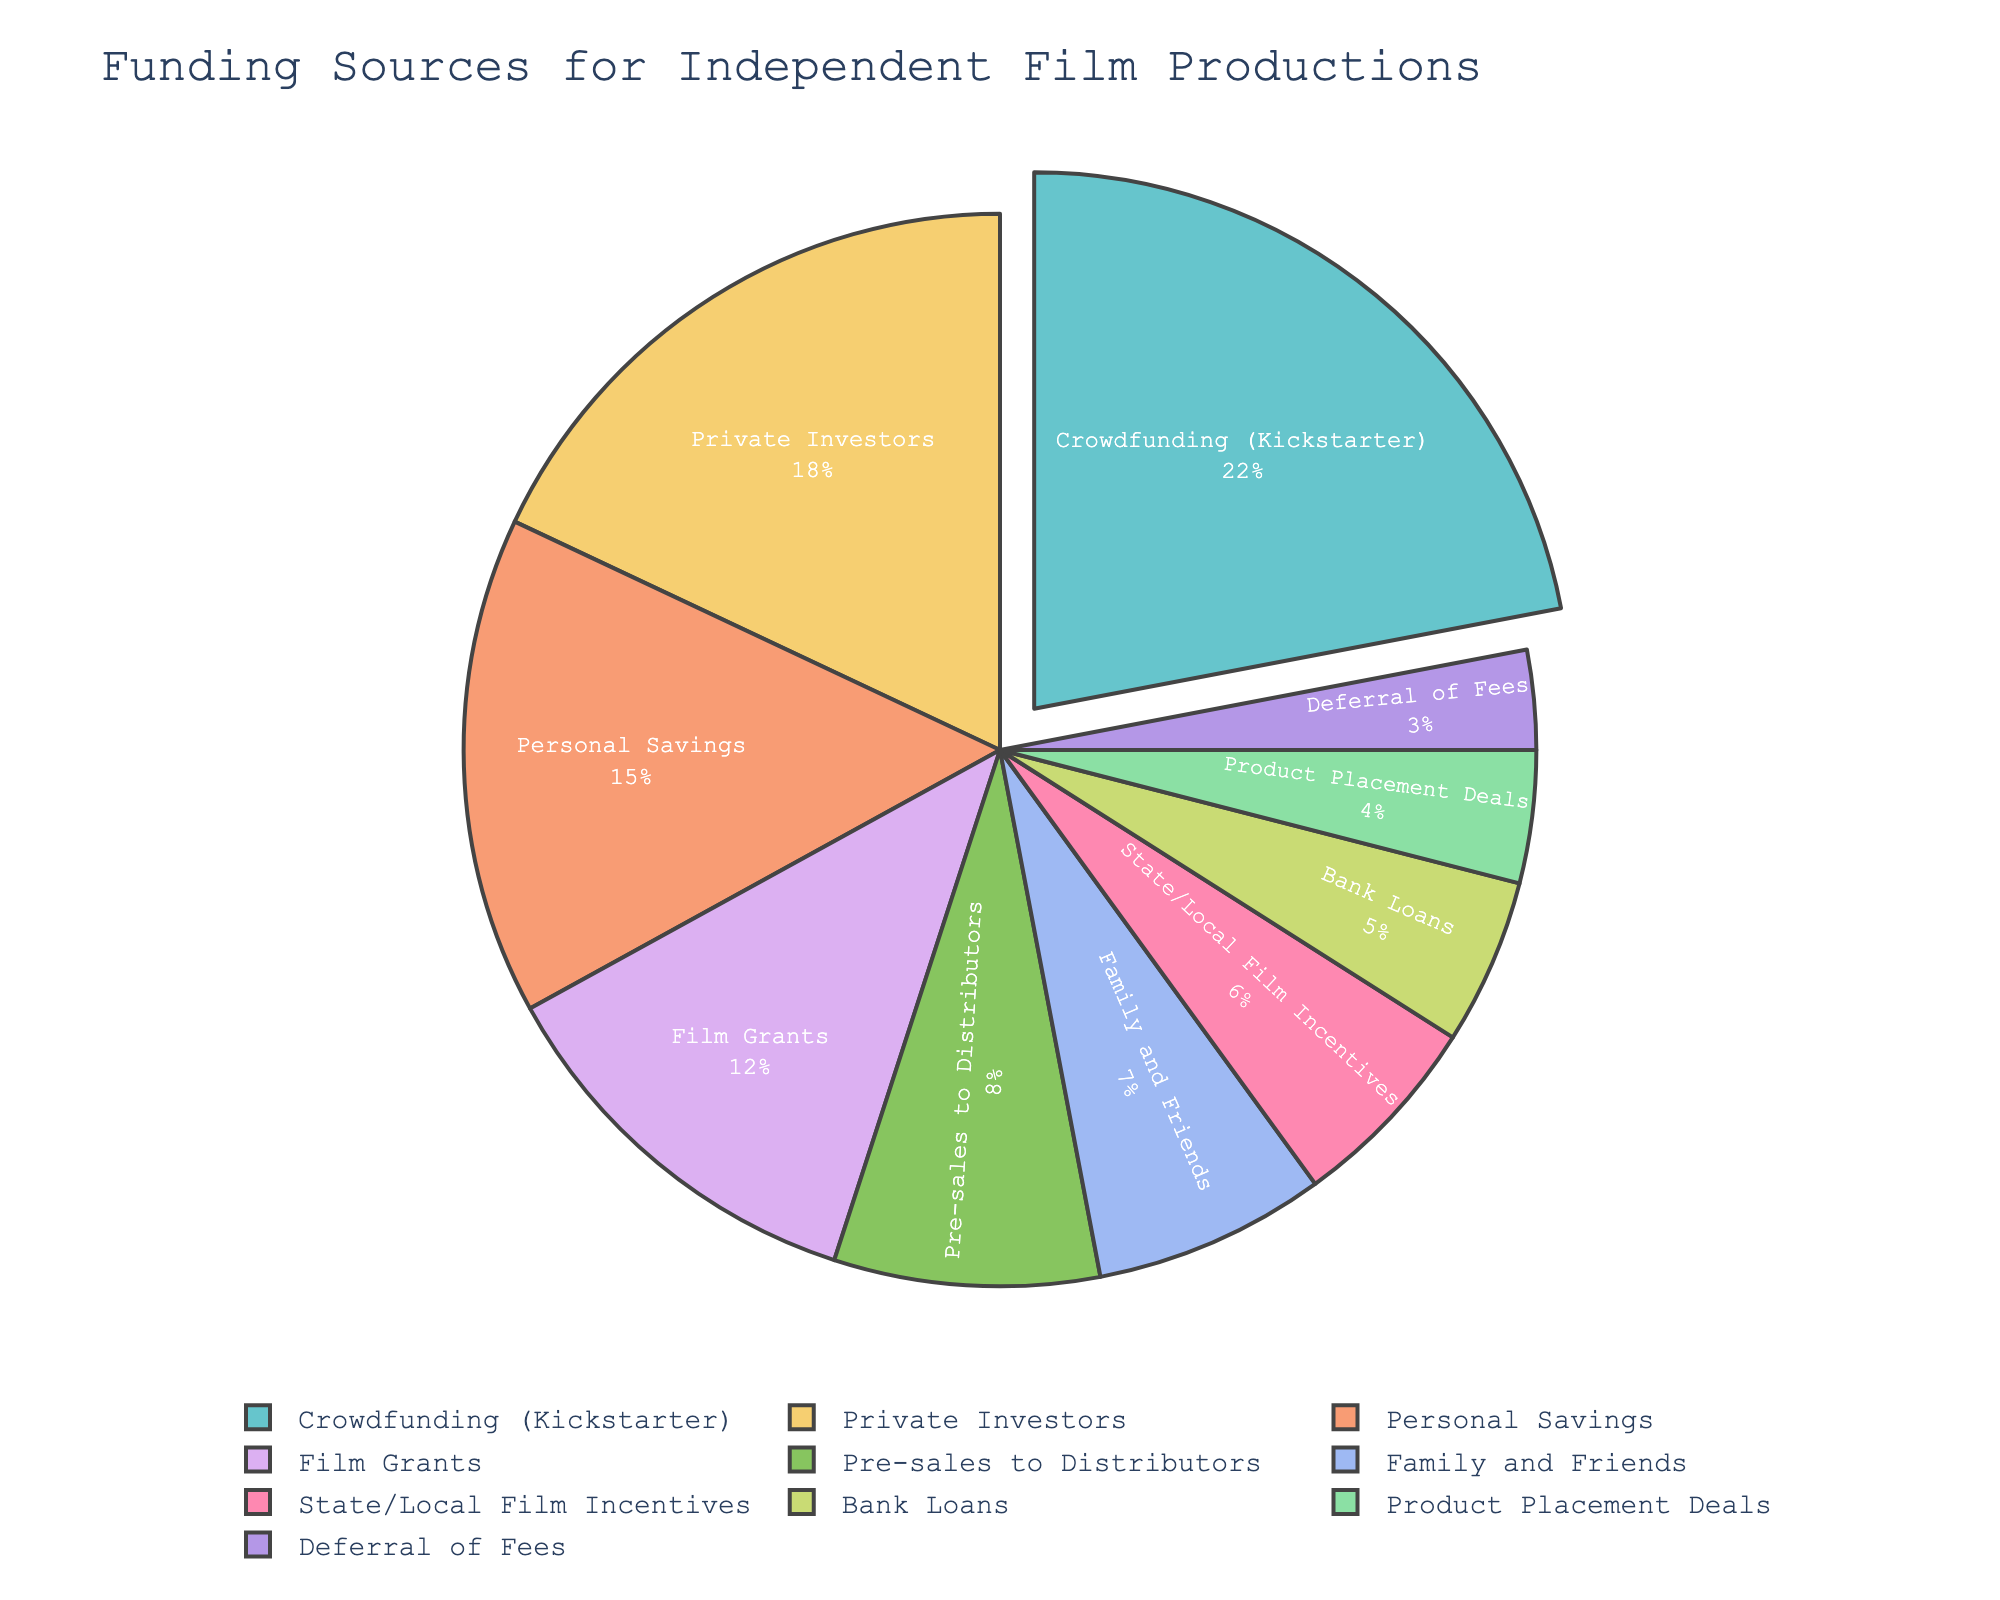Which funding source accounts for the largest percentage? From the pie chart, the slice representing the largest percentage is clearly identified and pulled out (highlighted) for better visual distinction. By examining the percent values on the pie slices, it is apparent that Crowdfunding (Kickstarter) has the largest percentage at 22%.
Answer: Crowdfunding (Kickstarter) Which two funding sources combined cover more than 30% of the total funding? First, identify the percentage values of each funding source from the pie chart. Adding the largest percentages, Crowdfunding (Kickstarter) at 22% and Personal Savings at 15%, yields 37%, which is more than 30%.
Answer: Crowdfunding (Kickstarter) and Personal Savings How much more prominent is the funding from Private Investors compared to State/Local Film Incentives? Determine the percentages of both Private Investors (18%) and State/Local Film Incentives (6%). Subtract the smaller percentage from the larger percentage: 18% - 6% = 12%.
Answer: 12% Which funding source has the smallest share, and what is its percentage? Scan the pie chart to locate the smallest slice. The percentage values reveal that Deferral of Fees is the smallest, with a share of 3%.
Answer: Deferral of Fees, 3% Are there any funding sources representing equal slices? If yes, which ones? Visually inspect the pie slices for equal sizes and verify by comparing the percentage values. Both State/Local Film Incentives and Family and Friends have similar sizes but not equal. Hence, no funding sources represent equal percentages.
Answer: No What's the total percentage of funding that comes from less traditional sources like Product Placement Deals and Deferral of Fees? Identify the percentages: Product Placement Deals at 4% and Deferral of Fees at 3%. Add these together: 4% + 3% = 7%.
Answer: 7% How does the percentage of funding from Film Grants compare to that from Pre-sales to Distributors? Locate both slices on the pie chart. Film Grants have 12% while Pre-sales to Distributors have 8%. Film Grants are larger by 4%.
Answer: Film Grants are 4% more What is the average percentage share of the top three funding sources? Identify the top three sources (Crowdfunding (Kickstarter) 22%, Private Investors 18%, and Personal Savings 15%). Calculate their sum (22% + 18% + 15% = 55%) and then find the average: 55% / 3 = 18.33%.
Answer: 18.33% What's the combined percentage of funding coming from Family and Friends, and Bank Loans? Locate both percentages, Family and Friends at 7% and Bank Loans at 5%. Add them together: 7% + 5% = 12%.
Answer: 12% If you exclude the top funding source, what would be the total percentage covered by the remaining sources? The top source is Crowdfunding (Kickstarter) at 22%. Sum all sources' percentages (100%) and subtract 22%: 100% - 22% = 78%.
Answer: 78% 